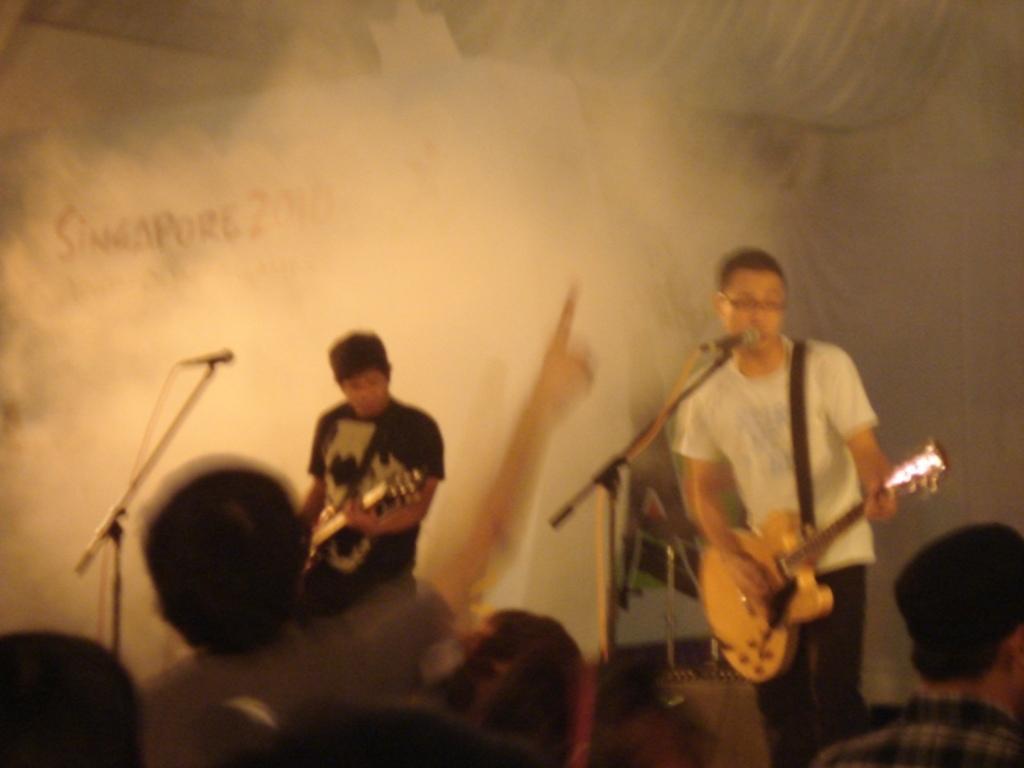In one or two sentences, can you explain what this image depicts? 2 people are playing guitar. at the front people are standing and watching them. 